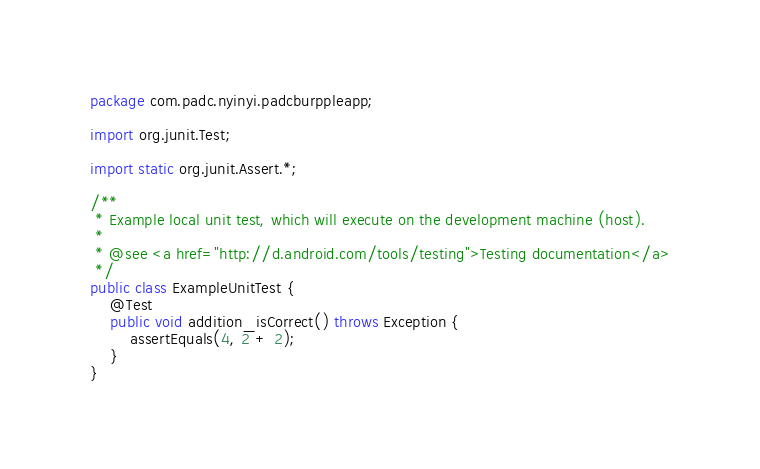Convert code to text. <code><loc_0><loc_0><loc_500><loc_500><_Java_>package com.padc.nyinyi.padcburppleapp;

import org.junit.Test;

import static org.junit.Assert.*;

/**
 * Example local unit test, which will execute on the development machine (host).
 *
 * @see <a href="http://d.android.com/tools/testing">Testing documentation</a>
 */
public class ExampleUnitTest {
    @Test
    public void addition_isCorrect() throws Exception {
        assertEquals(4, 2 + 2);
    }
}</code> 